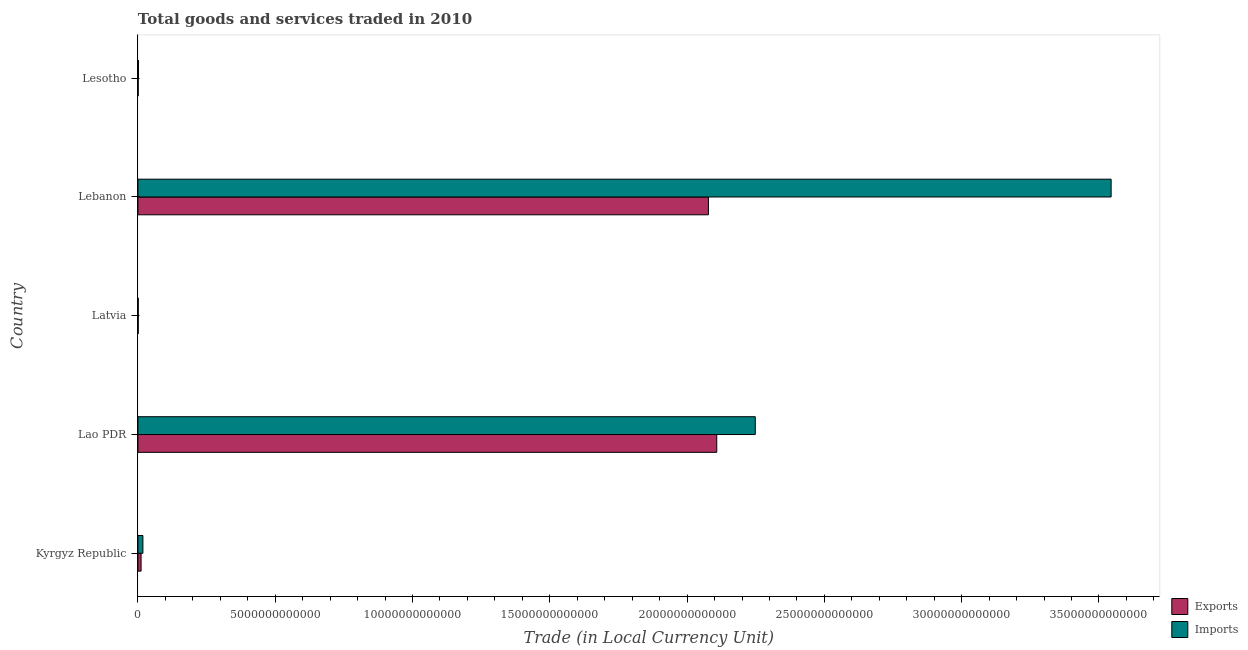How many groups of bars are there?
Your answer should be very brief. 5. Are the number of bars on each tick of the Y-axis equal?
Offer a very short reply. Yes. How many bars are there on the 5th tick from the bottom?
Offer a very short reply. 2. What is the label of the 5th group of bars from the top?
Provide a succinct answer. Kyrgyz Republic. In how many cases, is the number of bars for a given country not equal to the number of legend labels?
Provide a short and direct response. 0. What is the export of goods and services in Lebanon?
Your answer should be compact. 2.08e+13. Across all countries, what is the maximum imports of goods and services?
Your response must be concise. 3.54e+13. Across all countries, what is the minimum export of goods and services?
Offer a very short reply. 7.11e+09. In which country was the export of goods and services maximum?
Your response must be concise. Lao PDR. In which country was the imports of goods and services minimum?
Keep it short and to the point. Latvia. What is the total imports of goods and services in the graph?
Make the answer very short. 5.81e+13. What is the difference between the imports of goods and services in Lao PDR and that in Lesotho?
Make the answer very short. 2.25e+13. What is the difference between the export of goods and services in Lebanon and the imports of goods and services in Lao PDR?
Make the answer very short. -1.71e+12. What is the average export of goods and services per country?
Provide a short and direct response. 8.40e+12. What is the difference between the export of goods and services and imports of goods and services in Lesotho?
Keep it short and to the point. -1.07e+1. What is the ratio of the imports of goods and services in Kyrgyz Republic to that in Latvia?
Give a very brief answer. 18.2. Is the export of goods and services in Kyrgyz Republic less than that in Lebanon?
Give a very brief answer. Yes. What is the difference between the highest and the second highest export of goods and services?
Make the answer very short. 3.03e+11. What is the difference between the highest and the lowest export of goods and services?
Keep it short and to the point. 2.11e+13. Is the sum of the export of goods and services in Kyrgyz Republic and Lao PDR greater than the maximum imports of goods and services across all countries?
Ensure brevity in your answer.  No. What does the 2nd bar from the top in Kyrgyz Republic represents?
Provide a short and direct response. Exports. What does the 2nd bar from the bottom in Kyrgyz Republic represents?
Ensure brevity in your answer.  Imports. How many bars are there?
Offer a terse response. 10. Are all the bars in the graph horizontal?
Make the answer very short. Yes. How many countries are there in the graph?
Your answer should be very brief. 5. What is the difference between two consecutive major ticks on the X-axis?
Offer a very short reply. 5.00e+12. Are the values on the major ticks of X-axis written in scientific E-notation?
Provide a short and direct response. No. Where does the legend appear in the graph?
Your answer should be very brief. Bottom right. How many legend labels are there?
Provide a succinct answer. 2. What is the title of the graph?
Give a very brief answer. Total goods and services traded in 2010. Does "Food" appear as one of the legend labels in the graph?
Your response must be concise. No. What is the label or title of the X-axis?
Give a very brief answer. Trade (in Local Currency Unit). What is the Trade (in Local Currency Unit) of Exports in Kyrgyz Republic?
Offer a very short reply. 1.14e+11. What is the Trade (in Local Currency Unit) of Imports in Kyrgyz Republic?
Ensure brevity in your answer.  1.80e+11. What is the Trade (in Local Currency Unit) in Exports in Lao PDR?
Your answer should be compact. 2.11e+13. What is the Trade (in Local Currency Unit) in Imports in Lao PDR?
Ensure brevity in your answer.  2.25e+13. What is the Trade (in Local Currency Unit) in Exports in Latvia?
Provide a succinct answer. 9.62e+09. What is the Trade (in Local Currency Unit) in Imports in Latvia?
Make the answer very short. 9.89e+09. What is the Trade (in Local Currency Unit) in Exports in Lebanon?
Keep it short and to the point. 2.08e+13. What is the Trade (in Local Currency Unit) in Imports in Lebanon?
Your response must be concise. 3.54e+13. What is the Trade (in Local Currency Unit) of Exports in Lesotho?
Your answer should be compact. 7.11e+09. What is the Trade (in Local Currency Unit) in Imports in Lesotho?
Your answer should be very brief. 1.78e+1. Across all countries, what is the maximum Trade (in Local Currency Unit) in Exports?
Offer a very short reply. 2.11e+13. Across all countries, what is the maximum Trade (in Local Currency Unit) in Imports?
Ensure brevity in your answer.  3.54e+13. Across all countries, what is the minimum Trade (in Local Currency Unit) of Exports?
Offer a terse response. 7.11e+09. Across all countries, what is the minimum Trade (in Local Currency Unit) in Imports?
Provide a short and direct response. 9.89e+09. What is the total Trade (in Local Currency Unit) in Exports in the graph?
Ensure brevity in your answer.  4.20e+13. What is the total Trade (in Local Currency Unit) in Imports in the graph?
Ensure brevity in your answer.  5.81e+13. What is the difference between the Trade (in Local Currency Unit) in Exports in Kyrgyz Republic and that in Lao PDR?
Make the answer very short. -2.10e+13. What is the difference between the Trade (in Local Currency Unit) of Imports in Kyrgyz Republic and that in Lao PDR?
Ensure brevity in your answer.  -2.23e+13. What is the difference between the Trade (in Local Currency Unit) in Exports in Kyrgyz Republic and that in Latvia?
Provide a succinct answer. 1.04e+11. What is the difference between the Trade (in Local Currency Unit) in Imports in Kyrgyz Republic and that in Latvia?
Offer a very short reply. 1.70e+11. What is the difference between the Trade (in Local Currency Unit) in Exports in Kyrgyz Republic and that in Lebanon?
Ensure brevity in your answer.  -2.07e+13. What is the difference between the Trade (in Local Currency Unit) of Imports in Kyrgyz Republic and that in Lebanon?
Ensure brevity in your answer.  -3.53e+13. What is the difference between the Trade (in Local Currency Unit) of Exports in Kyrgyz Republic and that in Lesotho?
Ensure brevity in your answer.  1.07e+11. What is the difference between the Trade (in Local Currency Unit) of Imports in Kyrgyz Republic and that in Lesotho?
Your answer should be very brief. 1.62e+11. What is the difference between the Trade (in Local Currency Unit) in Exports in Lao PDR and that in Latvia?
Offer a very short reply. 2.11e+13. What is the difference between the Trade (in Local Currency Unit) in Imports in Lao PDR and that in Latvia?
Offer a very short reply. 2.25e+13. What is the difference between the Trade (in Local Currency Unit) of Exports in Lao PDR and that in Lebanon?
Your answer should be compact. 3.03e+11. What is the difference between the Trade (in Local Currency Unit) in Imports in Lao PDR and that in Lebanon?
Make the answer very short. -1.30e+13. What is the difference between the Trade (in Local Currency Unit) in Exports in Lao PDR and that in Lesotho?
Give a very brief answer. 2.11e+13. What is the difference between the Trade (in Local Currency Unit) in Imports in Lao PDR and that in Lesotho?
Make the answer very short. 2.25e+13. What is the difference between the Trade (in Local Currency Unit) in Exports in Latvia and that in Lebanon?
Your answer should be very brief. -2.08e+13. What is the difference between the Trade (in Local Currency Unit) in Imports in Latvia and that in Lebanon?
Give a very brief answer. -3.54e+13. What is the difference between the Trade (in Local Currency Unit) of Exports in Latvia and that in Lesotho?
Ensure brevity in your answer.  2.52e+09. What is the difference between the Trade (in Local Currency Unit) of Imports in Latvia and that in Lesotho?
Make the answer very short. -7.95e+09. What is the difference between the Trade (in Local Currency Unit) of Exports in Lebanon and that in Lesotho?
Offer a very short reply. 2.08e+13. What is the difference between the Trade (in Local Currency Unit) of Imports in Lebanon and that in Lesotho?
Your answer should be very brief. 3.54e+13. What is the difference between the Trade (in Local Currency Unit) in Exports in Kyrgyz Republic and the Trade (in Local Currency Unit) in Imports in Lao PDR?
Give a very brief answer. -2.24e+13. What is the difference between the Trade (in Local Currency Unit) of Exports in Kyrgyz Republic and the Trade (in Local Currency Unit) of Imports in Latvia?
Offer a terse response. 1.04e+11. What is the difference between the Trade (in Local Currency Unit) of Exports in Kyrgyz Republic and the Trade (in Local Currency Unit) of Imports in Lebanon?
Offer a terse response. -3.53e+13. What is the difference between the Trade (in Local Currency Unit) in Exports in Kyrgyz Republic and the Trade (in Local Currency Unit) in Imports in Lesotho?
Make the answer very short. 9.58e+1. What is the difference between the Trade (in Local Currency Unit) in Exports in Lao PDR and the Trade (in Local Currency Unit) in Imports in Latvia?
Your answer should be very brief. 2.11e+13. What is the difference between the Trade (in Local Currency Unit) in Exports in Lao PDR and the Trade (in Local Currency Unit) in Imports in Lebanon?
Provide a succinct answer. -1.44e+13. What is the difference between the Trade (in Local Currency Unit) in Exports in Lao PDR and the Trade (in Local Currency Unit) in Imports in Lesotho?
Provide a succinct answer. 2.11e+13. What is the difference between the Trade (in Local Currency Unit) in Exports in Latvia and the Trade (in Local Currency Unit) in Imports in Lebanon?
Keep it short and to the point. -3.54e+13. What is the difference between the Trade (in Local Currency Unit) of Exports in Latvia and the Trade (in Local Currency Unit) of Imports in Lesotho?
Offer a very short reply. -8.21e+09. What is the difference between the Trade (in Local Currency Unit) of Exports in Lebanon and the Trade (in Local Currency Unit) of Imports in Lesotho?
Your answer should be very brief. 2.08e+13. What is the average Trade (in Local Currency Unit) in Exports per country?
Give a very brief answer. 8.40e+12. What is the average Trade (in Local Currency Unit) of Imports per country?
Your response must be concise. 1.16e+13. What is the difference between the Trade (in Local Currency Unit) of Exports and Trade (in Local Currency Unit) of Imports in Kyrgyz Republic?
Provide a succinct answer. -6.64e+1. What is the difference between the Trade (in Local Currency Unit) of Exports and Trade (in Local Currency Unit) of Imports in Lao PDR?
Your response must be concise. -1.40e+12. What is the difference between the Trade (in Local Currency Unit) in Exports and Trade (in Local Currency Unit) in Imports in Latvia?
Provide a succinct answer. -2.64e+08. What is the difference between the Trade (in Local Currency Unit) of Exports and Trade (in Local Currency Unit) of Imports in Lebanon?
Keep it short and to the point. -1.47e+13. What is the difference between the Trade (in Local Currency Unit) of Exports and Trade (in Local Currency Unit) of Imports in Lesotho?
Offer a terse response. -1.07e+1. What is the ratio of the Trade (in Local Currency Unit) in Exports in Kyrgyz Republic to that in Lao PDR?
Keep it short and to the point. 0.01. What is the ratio of the Trade (in Local Currency Unit) in Imports in Kyrgyz Republic to that in Lao PDR?
Make the answer very short. 0.01. What is the ratio of the Trade (in Local Currency Unit) in Exports in Kyrgyz Republic to that in Latvia?
Provide a short and direct response. 11.8. What is the ratio of the Trade (in Local Currency Unit) in Imports in Kyrgyz Republic to that in Latvia?
Provide a short and direct response. 18.2. What is the ratio of the Trade (in Local Currency Unit) in Exports in Kyrgyz Republic to that in Lebanon?
Give a very brief answer. 0.01. What is the ratio of the Trade (in Local Currency Unit) of Imports in Kyrgyz Republic to that in Lebanon?
Provide a succinct answer. 0.01. What is the ratio of the Trade (in Local Currency Unit) in Exports in Kyrgyz Republic to that in Lesotho?
Your answer should be compact. 15.99. What is the ratio of the Trade (in Local Currency Unit) of Imports in Kyrgyz Republic to that in Lesotho?
Make the answer very short. 10.09. What is the ratio of the Trade (in Local Currency Unit) in Exports in Lao PDR to that in Latvia?
Provide a short and direct response. 2190.16. What is the ratio of the Trade (in Local Currency Unit) in Imports in Lao PDR to that in Latvia?
Your answer should be very brief. 2273.49. What is the ratio of the Trade (in Local Currency Unit) in Exports in Lao PDR to that in Lebanon?
Your response must be concise. 1.01. What is the ratio of the Trade (in Local Currency Unit) in Imports in Lao PDR to that in Lebanon?
Your answer should be very brief. 0.63. What is the ratio of the Trade (in Local Currency Unit) of Exports in Lao PDR to that in Lesotho?
Your answer should be very brief. 2966.3. What is the ratio of the Trade (in Local Currency Unit) of Imports in Lao PDR to that in Lesotho?
Your answer should be compact. 1260.43. What is the ratio of the Trade (in Local Currency Unit) in Exports in Latvia to that in Lebanon?
Your response must be concise. 0. What is the ratio of the Trade (in Local Currency Unit) in Imports in Latvia to that in Lebanon?
Give a very brief answer. 0. What is the ratio of the Trade (in Local Currency Unit) in Exports in Latvia to that in Lesotho?
Offer a very short reply. 1.35. What is the ratio of the Trade (in Local Currency Unit) in Imports in Latvia to that in Lesotho?
Give a very brief answer. 0.55. What is the ratio of the Trade (in Local Currency Unit) of Exports in Lebanon to that in Lesotho?
Provide a succinct answer. 2923.63. What is the ratio of the Trade (in Local Currency Unit) of Imports in Lebanon to that in Lesotho?
Keep it short and to the point. 1987. What is the difference between the highest and the second highest Trade (in Local Currency Unit) in Exports?
Your answer should be very brief. 3.03e+11. What is the difference between the highest and the second highest Trade (in Local Currency Unit) in Imports?
Your answer should be compact. 1.30e+13. What is the difference between the highest and the lowest Trade (in Local Currency Unit) in Exports?
Your answer should be very brief. 2.11e+13. What is the difference between the highest and the lowest Trade (in Local Currency Unit) in Imports?
Your response must be concise. 3.54e+13. 